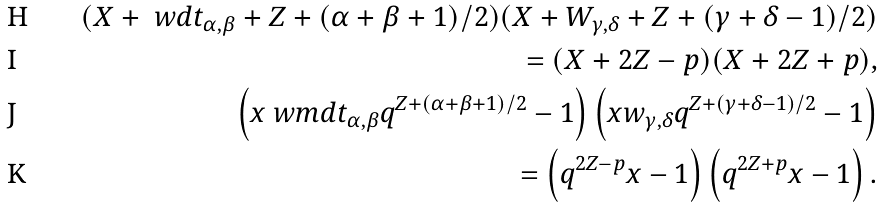<formula> <loc_0><loc_0><loc_500><loc_500>( X + \ w d t _ { \alpha , \beta } + Z + ( \alpha + \beta + 1 ) / 2 ) ( X + W _ { \gamma , \delta } + Z + ( \gamma + \delta - 1 ) / 2 ) \\ = ( X + 2 Z - p ) ( X + 2 Z + p ) , \\ \left ( x \ w m d t _ { \alpha , \beta } q ^ { Z + ( \alpha + \beta + 1 ) / 2 } - 1 \right ) \left ( x w _ { \gamma , \delta } q ^ { Z + ( \gamma + \delta - 1 ) / 2 } - 1 \right ) \\ = \left ( q ^ { 2 Z - p } x - 1 \right ) \left ( q ^ { 2 Z + p } x - 1 \right ) .</formula> 